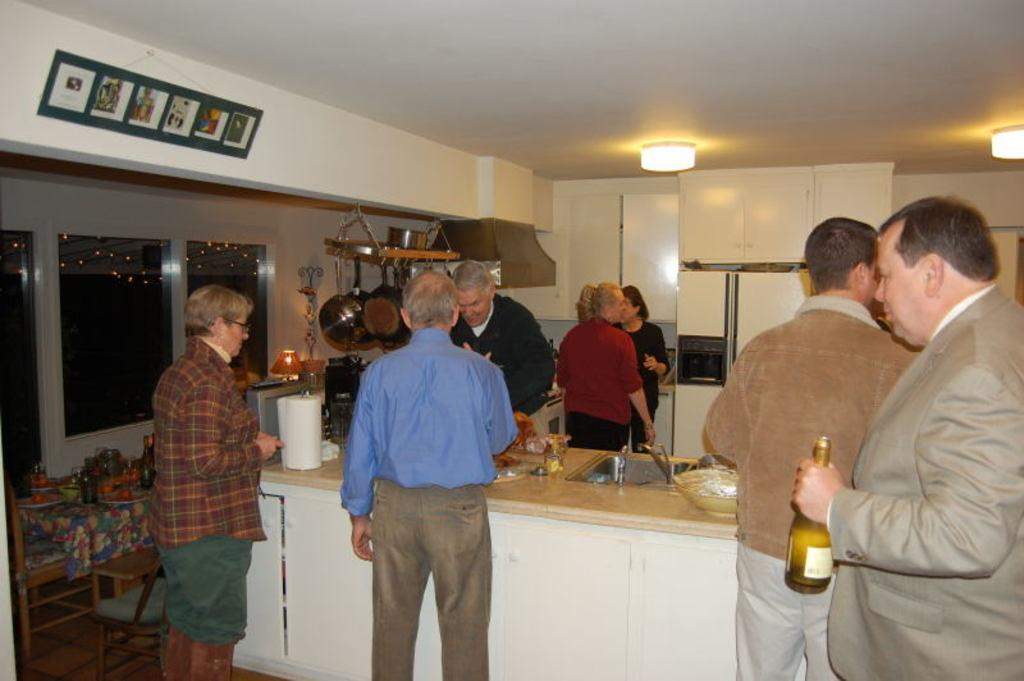How many people are in the image? There is a group of people in the image. What are the people doing in the image? The people are standing in the image. What is in front of the people? There is a table in front of the people. What can be found on the table? There are eatables on the table. What type of roof can be seen in the image? There is no roof visible in the image. How many boys are present in the image? The provided facts do not mention the gender of the people in the image, so it is impossible to determine the number of boys. 